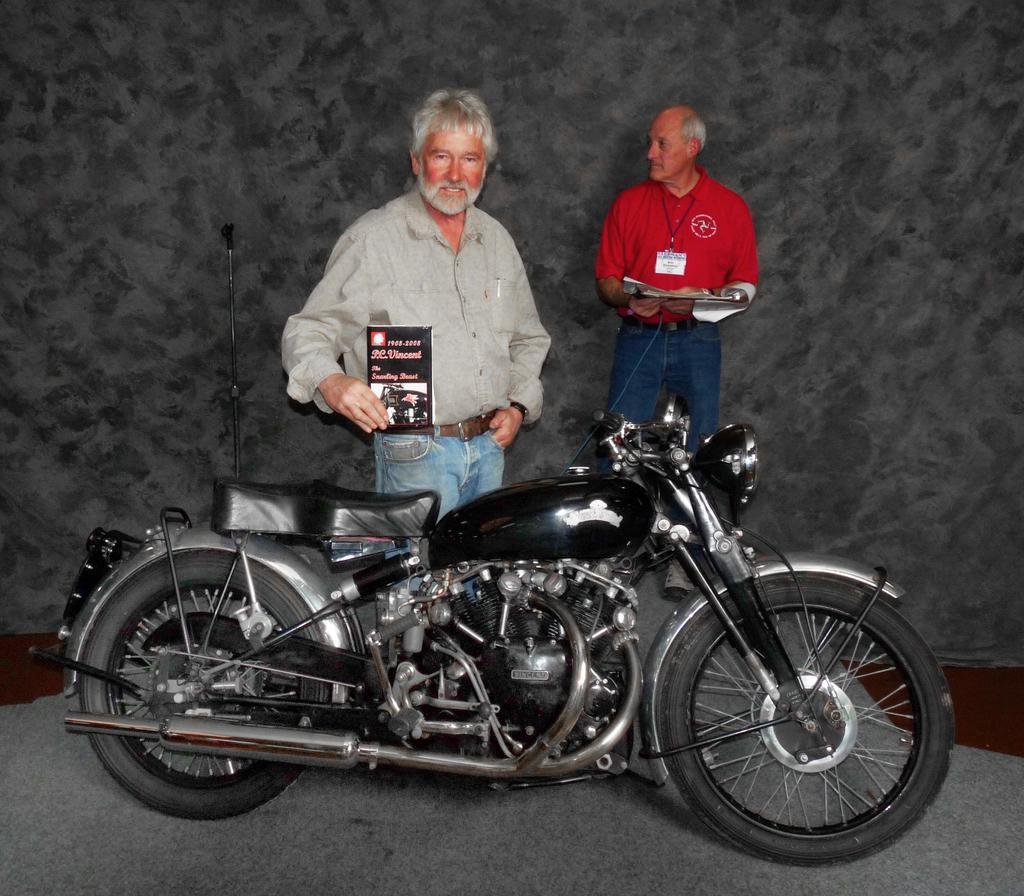Describe this image in one or two sentences. There is a bike in the center of the image and a man behind the bike, by holding a pamphlet in his hand. There is another man by holding papers in his hands in the background area. 